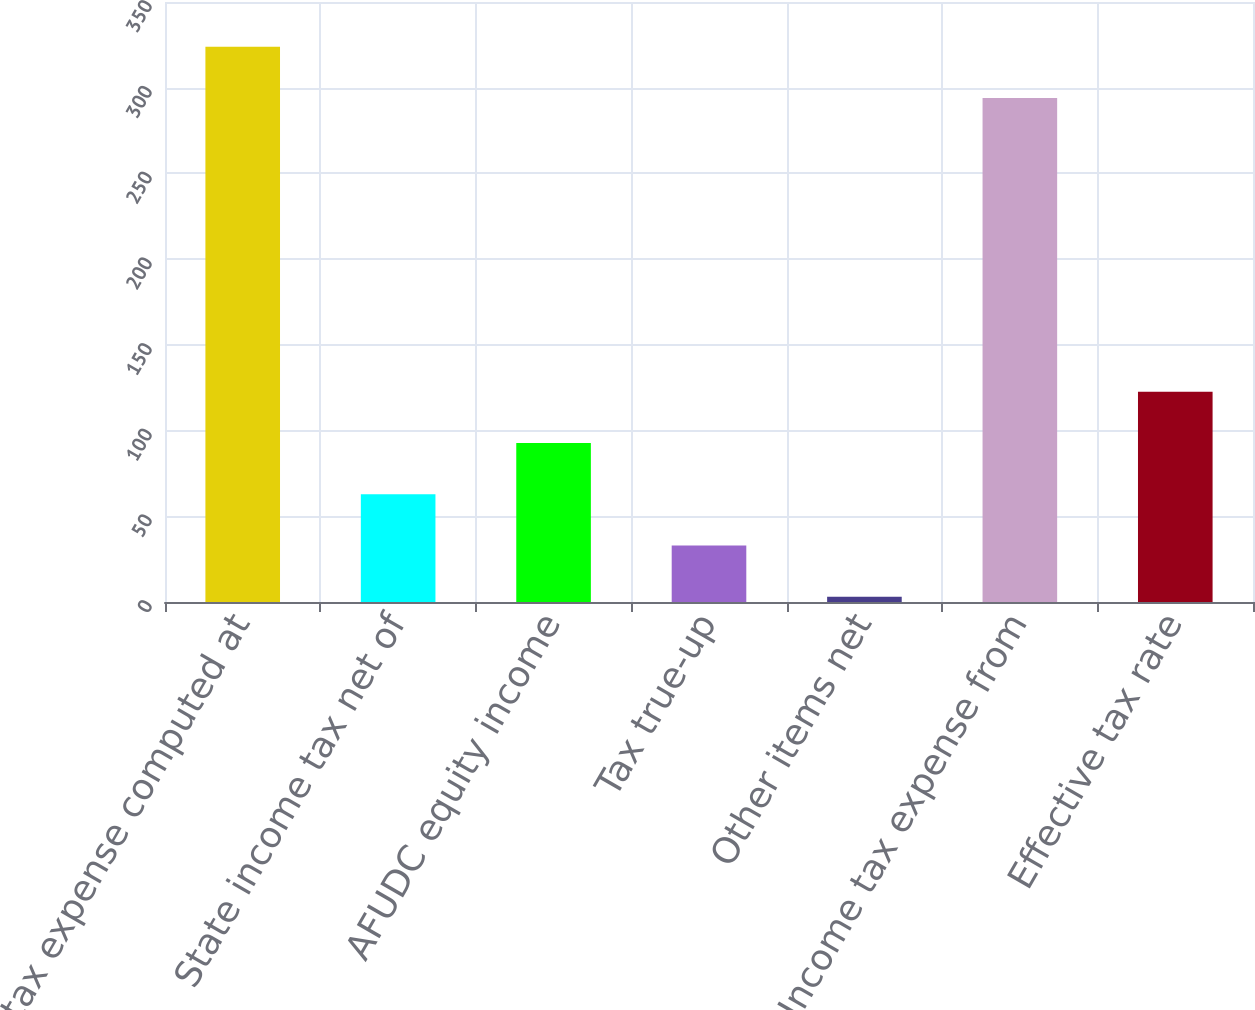Convert chart to OTSL. <chart><loc_0><loc_0><loc_500><loc_500><bar_chart><fcel>Income tax expense computed at<fcel>State income tax net of<fcel>AFUDC equity income<fcel>Tax true-up<fcel>Other items net<fcel>Income tax expense from<fcel>Effective tax rate<nl><fcel>323.9<fcel>62.8<fcel>92.7<fcel>32.9<fcel>3<fcel>294<fcel>122.6<nl></chart> 